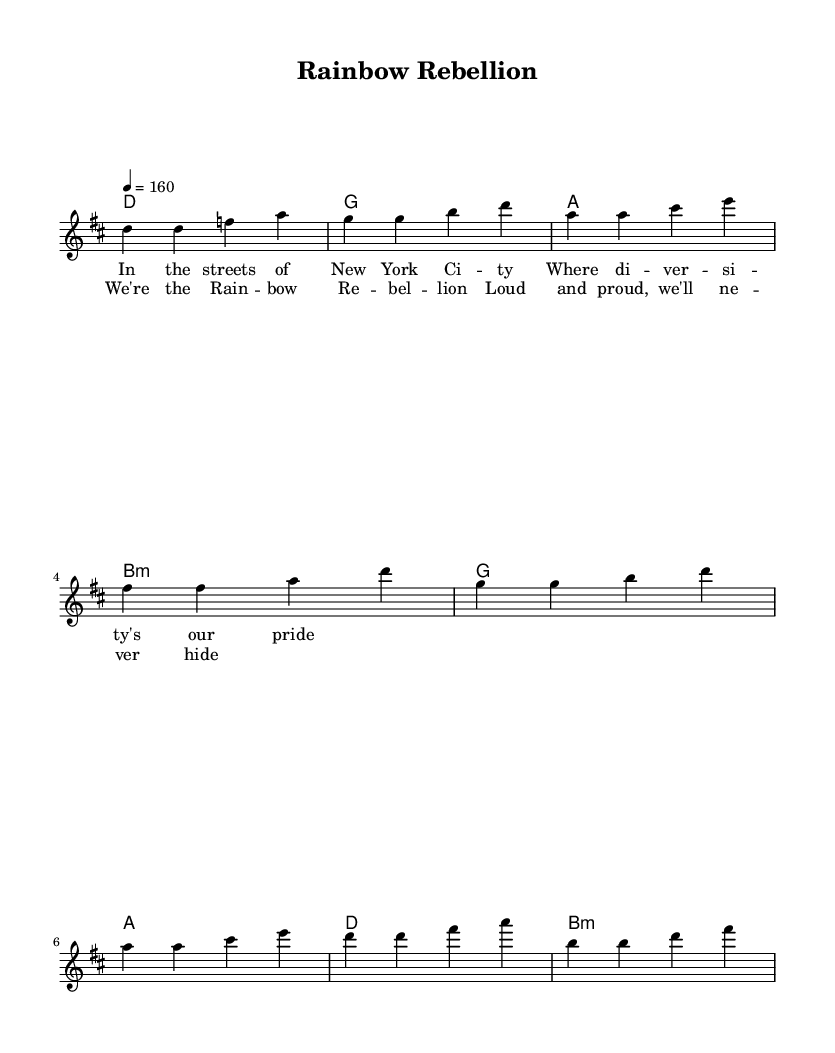What is the key signature of this music? The key signature is D major, which has two sharps (F# and C#).
Answer: D major What is the time signature of this music? The time signature is 4/4, meaning there are four beats in each measure.
Answer: 4/4 What is the tempo marking of this piece? The tempo marking is "4 = 160", indicating a speed of 160 beats per minute.
Answer: 160 How many measures are in the verse section? The verse section consists of four measures as indicated in the melody.
Answer: 4 What is the primary theme expressed in the lyrics? The primary theme expressed in the lyrics celebrates diversity and pride in the LGBTQ+ community.
Answer: Rainbow rebellion What chord follows the G chord in the chorus? The chord that follows the G chord in the chorus is the A chord.
Answer: A How is the song structured in terms of sections? The song is structured into verses and a chorus, alternating between them.
Answer: Verse and chorus 